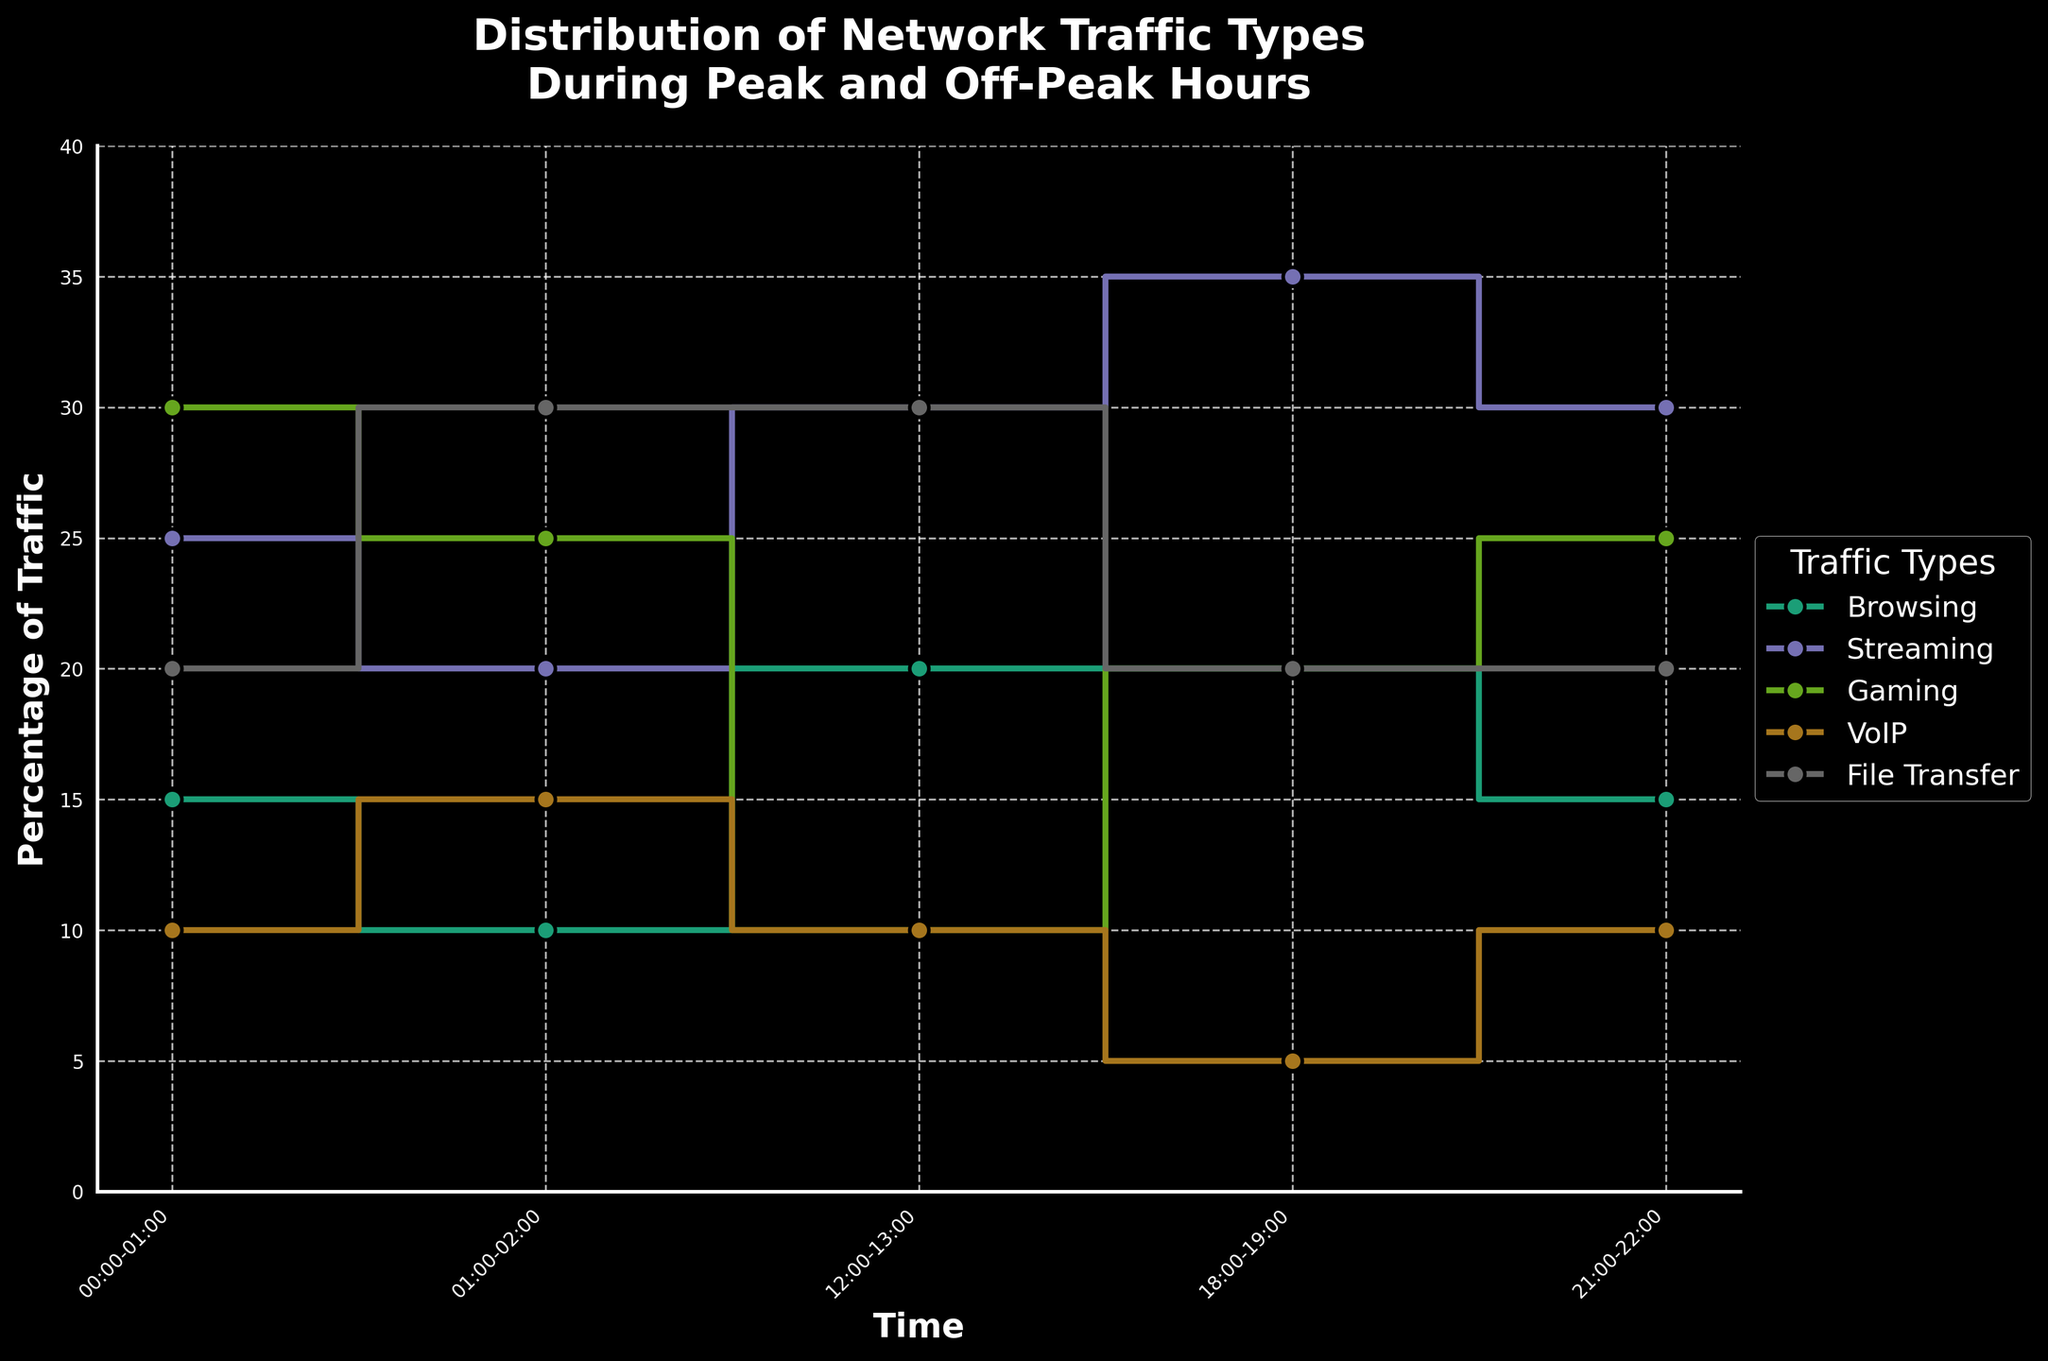What is the percentage of Streaming traffic at 18:00-19:00? To find this, look at the Streaming data point on the x-axis for the hour 18:00-19:00. The y-axis shows it as 35%.
Answer: 35% What is the total percentage of Browsing and VoIP traffic at 00:00-01:00? Add the percentages of Browsing (15%) and VoIP (10%) traffic at 00:00-01:00.
Answer: 25% How does the percentage of Gaming traffic change from 01:00-02:00 to 12:00-13:00? Subtract the Gaming percentage at 12:00-13:00 (10%) from the percentage at 01:00-02:00 (25%).
Answer: Decrease by 15% Which traffic type has the highest percentage during 12:00-13:00? Look at all traffic types during 12:00-13:00 and note their percentages. Streaming has the highest at 30%.
Answer: Streaming Is the percentage of File Transfer traffic ever greater than 30% during any hour? Check all File Transfer data points. None exceed 30%.
Answer: No During which hour is the percentage of VoIP traffic the lowest? Look at the VoIP data across all hours. It is lowest at 18:00-19:00 with 5%.
Answer: 18:00-19:00 Which hour has the most even distribution of all traffic types? Examine each hour to see the percentages; 21:00-22:00 seems most even as differences between percentages are smaller.
Answer: 21:00-22:00 During off-peak hours (00:00-01:00), which traffic type experienced the highest surge in percentage compared to peak hours (18:00-19:00)? Compare the percentages from 00:00-01:00 and 18:00-19:00. Gaming surges from 20% (18:00-19:00) to 30% (00:00-01:00).
Answer: Gaming What is the range of the percentage for Streaming traffic across all hours? Find the maximum and minimum percentages for Streaming (35% at 18:00-19:00 and 20% at 01:00-02:00). The range is 35% - 20%.
Answer: 15% Which traffic type shows the most significant decrease in percentage from 21:00-22:00 to 01:00-02:00? Compare the percentages of all traffic types between 21:00-22:00 and 01:00-02:00; Gaming drops from 25% to 25%. Hence no significant decrease.
Answer: None What time interval is ideal for conducting file transfers based on percentage distribution? File Transfer is highest at 01:00-02:00 with 30%, making it the ideal time interval.
Answer: 01:00-02:00 